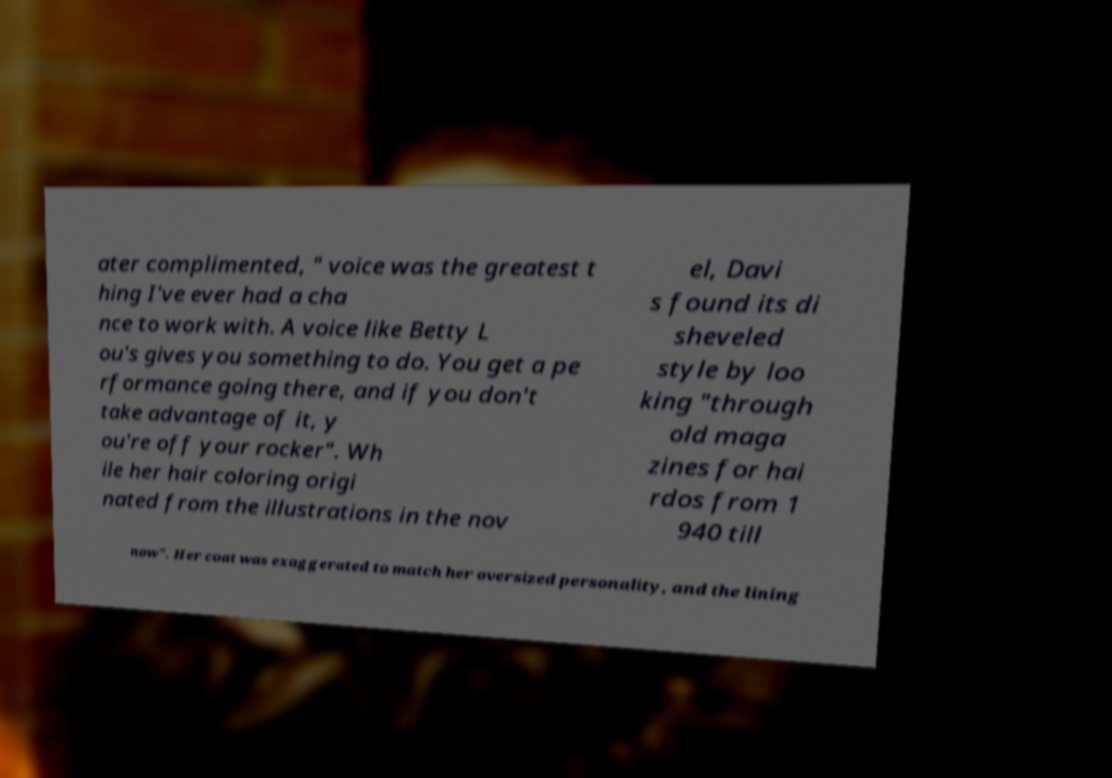Could you assist in decoding the text presented in this image and type it out clearly? ater complimented, " voice was the greatest t hing I've ever had a cha nce to work with. A voice like Betty L ou's gives you something to do. You get a pe rformance going there, and if you don't take advantage of it, y ou're off your rocker". Wh ile her hair coloring origi nated from the illustrations in the nov el, Davi s found its di sheveled style by loo king "through old maga zines for hai rdos from 1 940 till now". Her coat was exaggerated to match her oversized personality, and the lining 